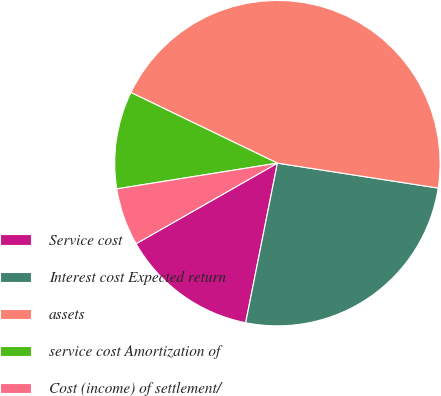Convert chart to OTSL. <chart><loc_0><loc_0><loc_500><loc_500><pie_chart><fcel>Service cost<fcel>Interest cost Expected return<fcel>assets<fcel>service cost Amortization of<fcel>Cost (income) of settlement/<nl><fcel>13.63%<fcel>25.68%<fcel>45.3%<fcel>9.68%<fcel>5.72%<nl></chart> 